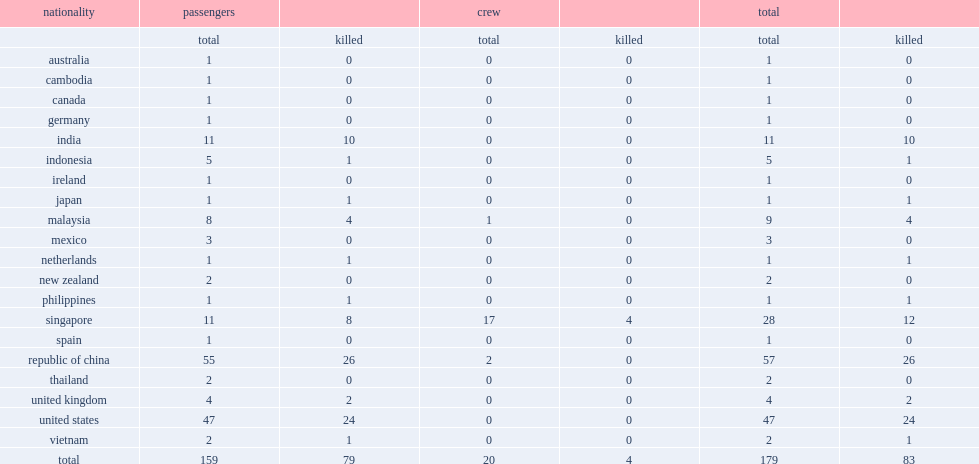How many passengers and crew were on the singapore airlines flight 006 aircraft? 179.0. 